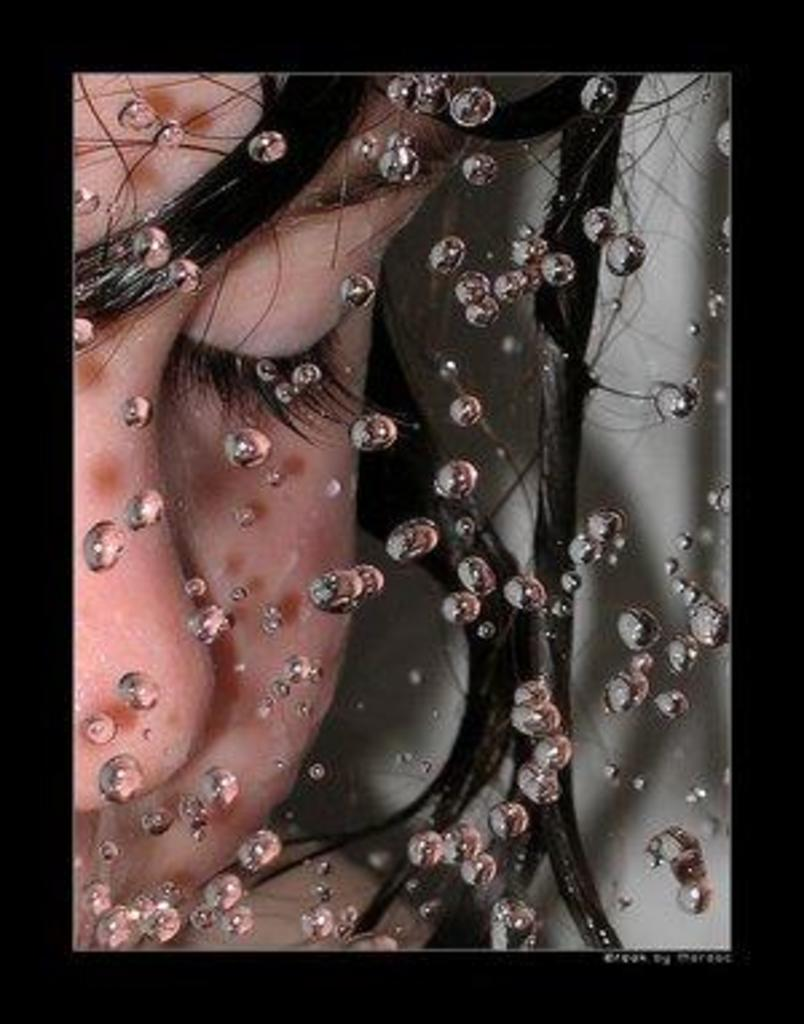Who or what is present in the image? There is a person in the image. What is the person doing in the image? The person is closing their eyes. What can be seen in the front of the image? There are many water bubbles in the front of the image. What color is the moon in the image? There is no moon present in the image. What type of flag is visible in the image? There is no flag present in the image. 